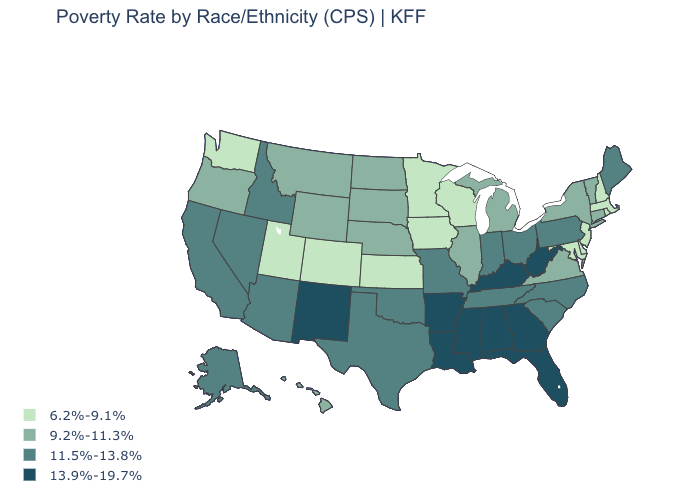What is the value of Idaho?
Concise answer only. 11.5%-13.8%. Which states hav the highest value in the West?
Answer briefly. New Mexico. Among the states that border Oregon , which have the highest value?
Short answer required. California, Idaho, Nevada. Does South Carolina have the same value as California?
Give a very brief answer. Yes. Is the legend a continuous bar?
Quick response, please. No. Name the states that have a value in the range 9.2%-11.3%?
Quick response, please. Connecticut, Hawaii, Illinois, Michigan, Montana, Nebraska, New York, North Dakota, Oregon, South Dakota, Vermont, Virginia, Wyoming. Name the states that have a value in the range 6.2%-9.1%?
Give a very brief answer. Colorado, Delaware, Iowa, Kansas, Maryland, Massachusetts, Minnesota, New Hampshire, New Jersey, Rhode Island, Utah, Washington, Wisconsin. Which states have the lowest value in the South?
Quick response, please. Delaware, Maryland. Does Kentucky have a higher value than West Virginia?
Give a very brief answer. No. Among the states that border Arizona , does Utah have the lowest value?
Concise answer only. Yes. Does Hawaii have the lowest value in the West?
Quick response, please. No. Does the map have missing data?
Write a very short answer. No. What is the value of Oklahoma?
Short answer required. 11.5%-13.8%. Does Iowa have a higher value than South Dakota?
Concise answer only. No. Name the states that have a value in the range 6.2%-9.1%?
Answer briefly. Colorado, Delaware, Iowa, Kansas, Maryland, Massachusetts, Minnesota, New Hampshire, New Jersey, Rhode Island, Utah, Washington, Wisconsin. 